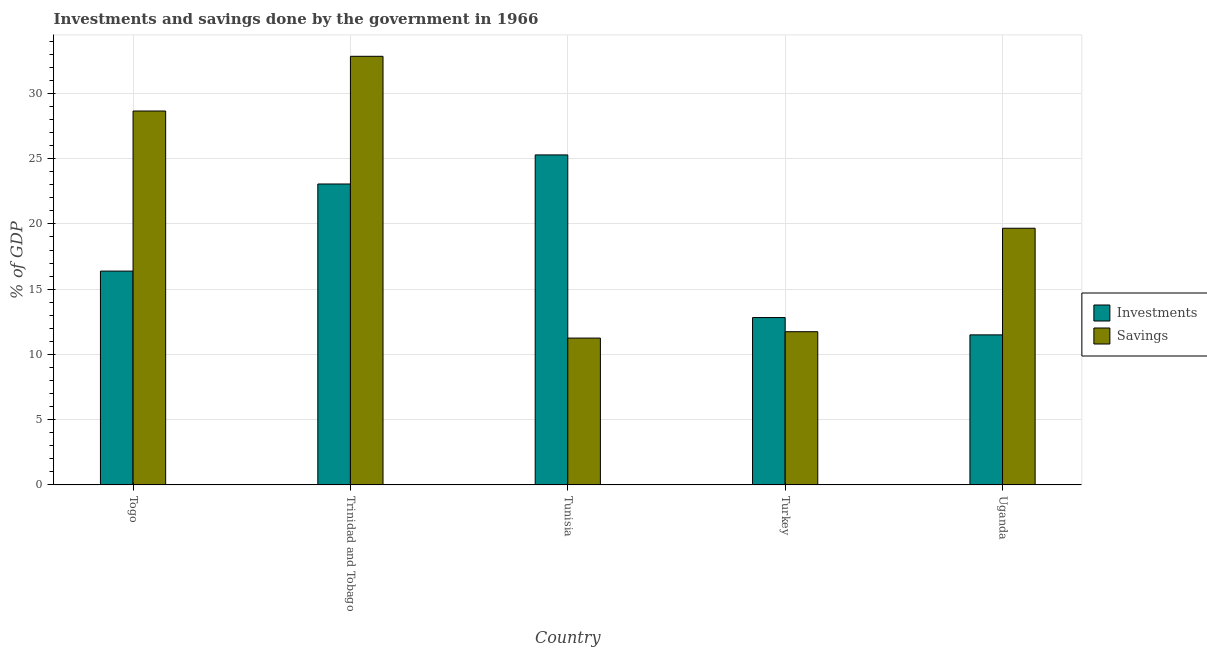How many different coloured bars are there?
Provide a short and direct response. 2. How many groups of bars are there?
Offer a terse response. 5. How many bars are there on the 1st tick from the left?
Provide a short and direct response. 2. How many bars are there on the 3rd tick from the right?
Offer a very short reply. 2. What is the label of the 1st group of bars from the left?
Your answer should be very brief. Togo. In how many cases, is the number of bars for a given country not equal to the number of legend labels?
Make the answer very short. 0. What is the savings of government in Tunisia?
Offer a terse response. 11.25. Across all countries, what is the maximum savings of government?
Offer a terse response. 32.85. Across all countries, what is the minimum investments of government?
Offer a terse response. 11.5. In which country was the investments of government maximum?
Make the answer very short. Tunisia. In which country was the savings of government minimum?
Give a very brief answer. Tunisia. What is the total savings of government in the graph?
Offer a terse response. 104.16. What is the difference between the investments of government in Turkey and that in Uganda?
Your answer should be very brief. 1.33. What is the difference between the investments of government in Turkey and the savings of government in Trinidad and Tobago?
Offer a very short reply. -20.02. What is the average investments of government per country?
Your answer should be very brief. 17.81. What is the difference between the savings of government and investments of government in Togo?
Ensure brevity in your answer.  12.27. What is the ratio of the investments of government in Togo to that in Uganda?
Make the answer very short. 1.42. Is the savings of government in Trinidad and Tobago less than that in Uganda?
Keep it short and to the point. No. Is the difference between the investments of government in Turkey and Uganda greater than the difference between the savings of government in Turkey and Uganda?
Provide a succinct answer. Yes. What is the difference between the highest and the second highest savings of government?
Offer a very short reply. 4.19. What is the difference between the highest and the lowest savings of government?
Provide a short and direct response. 21.59. What does the 1st bar from the left in Turkey represents?
Offer a very short reply. Investments. What does the 1st bar from the right in Togo represents?
Ensure brevity in your answer.  Savings. Are all the bars in the graph horizontal?
Provide a short and direct response. No. How many countries are there in the graph?
Make the answer very short. 5. Does the graph contain any zero values?
Offer a very short reply. No. How are the legend labels stacked?
Provide a succinct answer. Vertical. What is the title of the graph?
Make the answer very short. Investments and savings done by the government in 1966. Does "Primary school" appear as one of the legend labels in the graph?
Your response must be concise. No. What is the label or title of the X-axis?
Ensure brevity in your answer.  Country. What is the label or title of the Y-axis?
Your answer should be very brief. % of GDP. What is the % of GDP of Investments in Togo?
Ensure brevity in your answer.  16.38. What is the % of GDP in Savings in Togo?
Give a very brief answer. 28.65. What is the % of GDP in Investments in Trinidad and Tobago?
Keep it short and to the point. 23.06. What is the % of GDP in Savings in Trinidad and Tobago?
Provide a succinct answer. 32.85. What is the % of GDP of Investments in Tunisia?
Provide a succinct answer. 25.29. What is the % of GDP of Savings in Tunisia?
Keep it short and to the point. 11.25. What is the % of GDP in Investments in Turkey?
Give a very brief answer. 12.82. What is the % of GDP of Savings in Turkey?
Make the answer very short. 11.74. What is the % of GDP in Investments in Uganda?
Ensure brevity in your answer.  11.5. What is the % of GDP in Savings in Uganda?
Give a very brief answer. 19.67. Across all countries, what is the maximum % of GDP in Investments?
Ensure brevity in your answer.  25.29. Across all countries, what is the maximum % of GDP of Savings?
Offer a terse response. 32.85. Across all countries, what is the minimum % of GDP in Investments?
Your answer should be compact. 11.5. Across all countries, what is the minimum % of GDP of Savings?
Keep it short and to the point. 11.25. What is the total % of GDP in Investments in the graph?
Keep it short and to the point. 89.05. What is the total % of GDP of Savings in the graph?
Your answer should be very brief. 104.16. What is the difference between the % of GDP in Investments in Togo and that in Trinidad and Tobago?
Offer a very short reply. -6.68. What is the difference between the % of GDP of Savings in Togo and that in Trinidad and Tobago?
Ensure brevity in your answer.  -4.19. What is the difference between the % of GDP of Investments in Togo and that in Tunisia?
Offer a very short reply. -8.9. What is the difference between the % of GDP in Savings in Togo and that in Tunisia?
Your answer should be compact. 17.4. What is the difference between the % of GDP in Investments in Togo and that in Turkey?
Make the answer very short. 3.56. What is the difference between the % of GDP in Savings in Togo and that in Turkey?
Give a very brief answer. 16.91. What is the difference between the % of GDP of Investments in Togo and that in Uganda?
Make the answer very short. 4.89. What is the difference between the % of GDP of Savings in Togo and that in Uganda?
Offer a terse response. 8.98. What is the difference between the % of GDP in Investments in Trinidad and Tobago and that in Tunisia?
Your answer should be compact. -2.23. What is the difference between the % of GDP in Savings in Trinidad and Tobago and that in Tunisia?
Provide a succinct answer. 21.59. What is the difference between the % of GDP in Investments in Trinidad and Tobago and that in Turkey?
Provide a succinct answer. 10.23. What is the difference between the % of GDP in Savings in Trinidad and Tobago and that in Turkey?
Offer a very short reply. 21.11. What is the difference between the % of GDP in Investments in Trinidad and Tobago and that in Uganda?
Offer a terse response. 11.56. What is the difference between the % of GDP of Savings in Trinidad and Tobago and that in Uganda?
Your answer should be compact. 13.18. What is the difference between the % of GDP of Investments in Tunisia and that in Turkey?
Provide a short and direct response. 12.46. What is the difference between the % of GDP in Savings in Tunisia and that in Turkey?
Your response must be concise. -0.49. What is the difference between the % of GDP of Investments in Tunisia and that in Uganda?
Offer a terse response. 13.79. What is the difference between the % of GDP of Savings in Tunisia and that in Uganda?
Your answer should be very brief. -8.42. What is the difference between the % of GDP of Investments in Turkey and that in Uganda?
Offer a very short reply. 1.33. What is the difference between the % of GDP in Savings in Turkey and that in Uganda?
Give a very brief answer. -7.93. What is the difference between the % of GDP of Investments in Togo and the % of GDP of Savings in Trinidad and Tobago?
Provide a succinct answer. -16.46. What is the difference between the % of GDP in Investments in Togo and the % of GDP in Savings in Tunisia?
Provide a succinct answer. 5.13. What is the difference between the % of GDP of Investments in Togo and the % of GDP of Savings in Turkey?
Your answer should be very brief. 4.64. What is the difference between the % of GDP of Investments in Togo and the % of GDP of Savings in Uganda?
Your answer should be very brief. -3.28. What is the difference between the % of GDP in Investments in Trinidad and Tobago and the % of GDP in Savings in Tunisia?
Provide a short and direct response. 11.81. What is the difference between the % of GDP in Investments in Trinidad and Tobago and the % of GDP in Savings in Turkey?
Provide a short and direct response. 11.32. What is the difference between the % of GDP in Investments in Trinidad and Tobago and the % of GDP in Savings in Uganda?
Keep it short and to the point. 3.39. What is the difference between the % of GDP in Investments in Tunisia and the % of GDP in Savings in Turkey?
Your answer should be compact. 13.55. What is the difference between the % of GDP in Investments in Tunisia and the % of GDP in Savings in Uganda?
Your response must be concise. 5.62. What is the difference between the % of GDP of Investments in Turkey and the % of GDP of Savings in Uganda?
Make the answer very short. -6.84. What is the average % of GDP in Investments per country?
Your response must be concise. 17.81. What is the average % of GDP of Savings per country?
Your response must be concise. 20.83. What is the difference between the % of GDP in Investments and % of GDP in Savings in Togo?
Your answer should be very brief. -12.27. What is the difference between the % of GDP in Investments and % of GDP in Savings in Trinidad and Tobago?
Offer a terse response. -9.79. What is the difference between the % of GDP of Investments and % of GDP of Savings in Tunisia?
Ensure brevity in your answer.  14.04. What is the difference between the % of GDP in Investments and % of GDP in Savings in Turkey?
Your answer should be very brief. 1.08. What is the difference between the % of GDP of Investments and % of GDP of Savings in Uganda?
Make the answer very short. -8.17. What is the ratio of the % of GDP of Investments in Togo to that in Trinidad and Tobago?
Provide a short and direct response. 0.71. What is the ratio of the % of GDP of Savings in Togo to that in Trinidad and Tobago?
Your answer should be very brief. 0.87. What is the ratio of the % of GDP in Investments in Togo to that in Tunisia?
Make the answer very short. 0.65. What is the ratio of the % of GDP of Savings in Togo to that in Tunisia?
Your answer should be compact. 2.55. What is the ratio of the % of GDP in Investments in Togo to that in Turkey?
Provide a short and direct response. 1.28. What is the ratio of the % of GDP in Savings in Togo to that in Turkey?
Provide a succinct answer. 2.44. What is the ratio of the % of GDP in Investments in Togo to that in Uganda?
Provide a succinct answer. 1.43. What is the ratio of the % of GDP of Savings in Togo to that in Uganda?
Ensure brevity in your answer.  1.46. What is the ratio of the % of GDP of Investments in Trinidad and Tobago to that in Tunisia?
Offer a very short reply. 0.91. What is the ratio of the % of GDP in Savings in Trinidad and Tobago to that in Tunisia?
Offer a terse response. 2.92. What is the ratio of the % of GDP in Investments in Trinidad and Tobago to that in Turkey?
Keep it short and to the point. 1.8. What is the ratio of the % of GDP of Savings in Trinidad and Tobago to that in Turkey?
Keep it short and to the point. 2.8. What is the ratio of the % of GDP in Investments in Trinidad and Tobago to that in Uganda?
Make the answer very short. 2.01. What is the ratio of the % of GDP of Savings in Trinidad and Tobago to that in Uganda?
Your answer should be very brief. 1.67. What is the ratio of the % of GDP in Investments in Tunisia to that in Turkey?
Offer a terse response. 1.97. What is the ratio of the % of GDP of Savings in Tunisia to that in Turkey?
Make the answer very short. 0.96. What is the ratio of the % of GDP in Investments in Tunisia to that in Uganda?
Give a very brief answer. 2.2. What is the ratio of the % of GDP of Savings in Tunisia to that in Uganda?
Make the answer very short. 0.57. What is the ratio of the % of GDP of Investments in Turkey to that in Uganda?
Offer a very short reply. 1.12. What is the ratio of the % of GDP in Savings in Turkey to that in Uganda?
Your answer should be very brief. 0.6. What is the difference between the highest and the second highest % of GDP in Investments?
Your answer should be compact. 2.23. What is the difference between the highest and the second highest % of GDP of Savings?
Provide a succinct answer. 4.19. What is the difference between the highest and the lowest % of GDP of Investments?
Your response must be concise. 13.79. What is the difference between the highest and the lowest % of GDP of Savings?
Offer a very short reply. 21.59. 